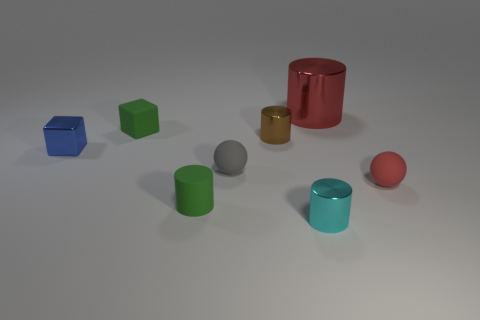Add 1 green rubber objects. How many objects exist? 9 Subtract all balls. How many objects are left? 6 Add 5 large brown metallic blocks. How many large brown metallic blocks exist? 5 Subtract 0 purple cylinders. How many objects are left? 8 Subtract all small shiny cylinders. Subtract all tiny red rubber spheres. How many objects are left? 5 Add 7 cyan metal objects. How many cyan metal objects are left? 8 